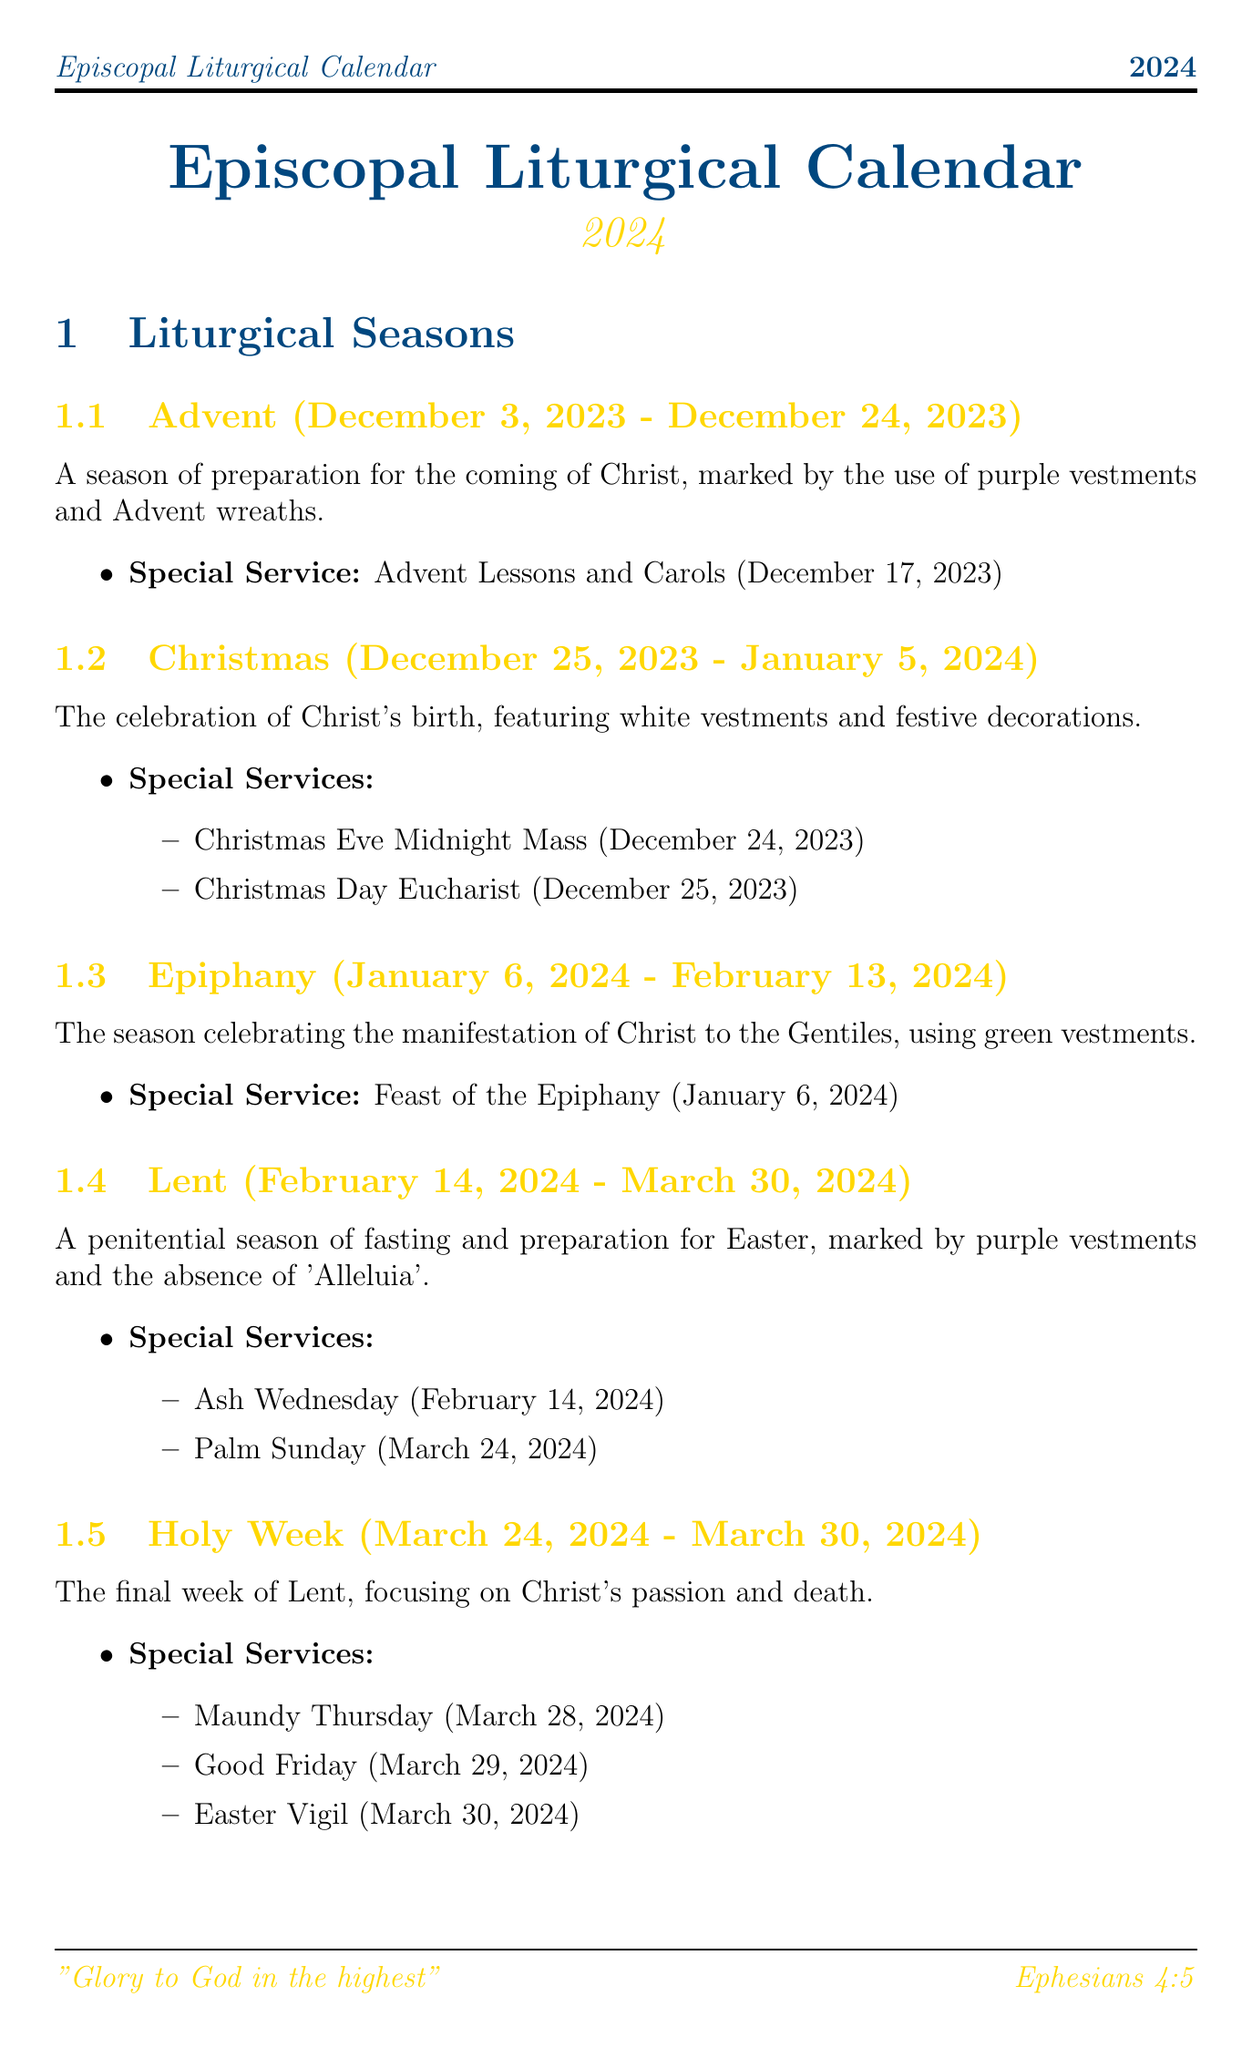What is the start date of Lent in 2024? The document specifies that Lent starts on February 14, 2024.
Answer: February 14, 2024 What special service is held on Christmas Eve? According to the document, the special service on Christmas Eve is the Midnight Mass.
Answer: Christmas Eve Midnight Mass What color vestments are used during the Epiphany season? The document mentions that green vestments are used during the Epiphany season.
Answer: Green What are the dates of Holy Week in 2024? The document lists the dates of Holy Week as March 24, 2024 to March 30, 2024.
Answer: March 24, 2024 - March 30, 2024 How many major feast days are listed in the document? The document includes a total of seven major feast days.
Answer: Seven Which feast day commemorates the announcement to Mary? The document states that the Annunciation commemorates the angel Gabriel's announcement to Mary.
Answer: The Annunciation What is the longest season of the church year? The document identifies Pentecost as the longest season of the church year.
Answer: Pentecost What special service marks the beginning of Lent? According to the document, Ash Wednesday marks the beginning of Lent.
Answer: Ash Wednesday What is the primary liturgical resource used in Episcopal worship? The document specifies that the Book of Common Prayer is the primary liturgical resource.
Answer: Book of Common Prayer 